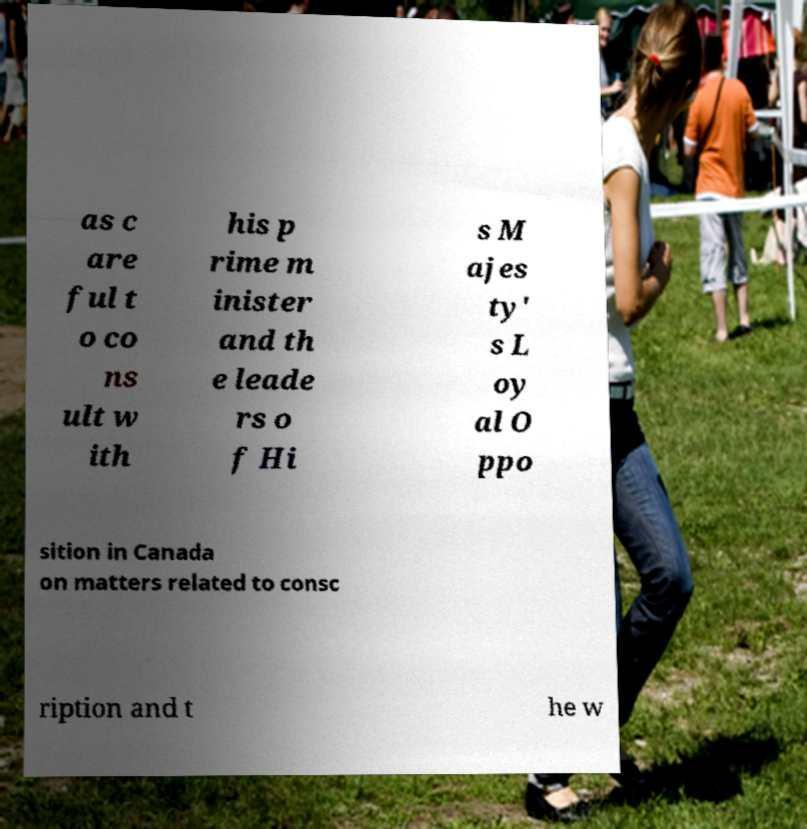Please identify and transcribe the text found in this image. as c are ful t o co ns ult w ith his p rime m inister and th e leade rs o f Hi s M ajes ty' s L oy al O ppo sition in Canada on matters related to consc ription and t he w 